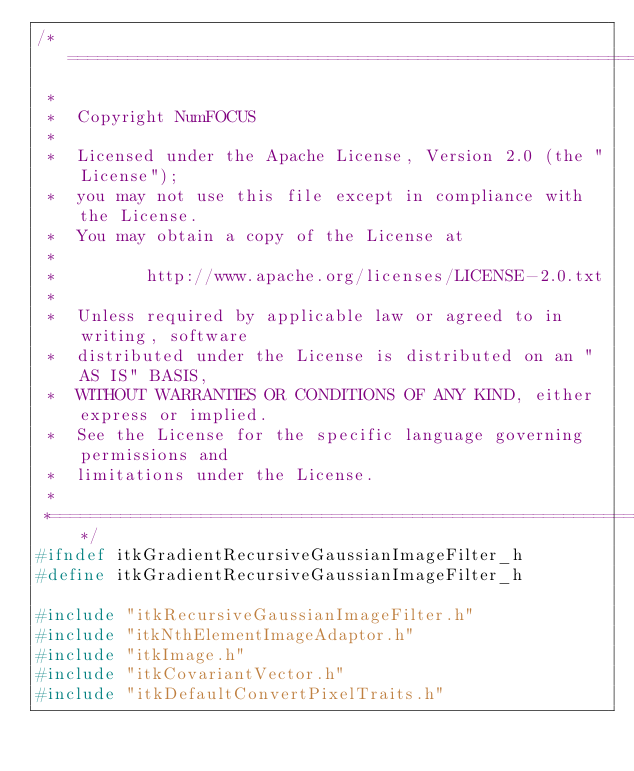Convert code to text. <code><loc_0><loc_0><loc_500><loc_500><_C_>/*=========================================================================
 *
 *  Copyright NumFOCUS
 *
 *  Licensed under the Apache License, Version 2.0 (the "License");
 *  you may not use this file except in compliance with the License.
 *  You may obtain a copy of the License at
 *
 *         http://www.apache.org/licenses/LICENSE-2.0.txt
 *
 *  Unless required by applicable law or agreed to in writing, software
 *  distributed under the License is distributed on an "AS IS" BASIS,
 *  WITHOUT WARRANTIES OR CONDITIONS OF ANY KIND, either express or implied.
 *  See the License for the specific language governing permissions and
 *  limitations under the License.
 *
 *=========================================================================*/
#ifndef itkGradientRecursiveGaussianImageFilter_h
#define itkGradientRecursiveGaussianImageFilter_h

#include "itkRecursiveGaussianImageFilter.h"
#include "itkNthElementImageAdaptor.h"
#include "itkImage.h"
#include "itkCovariantVector.h"
#include "itkDefaultConvertPixelTraits.h"</code> 